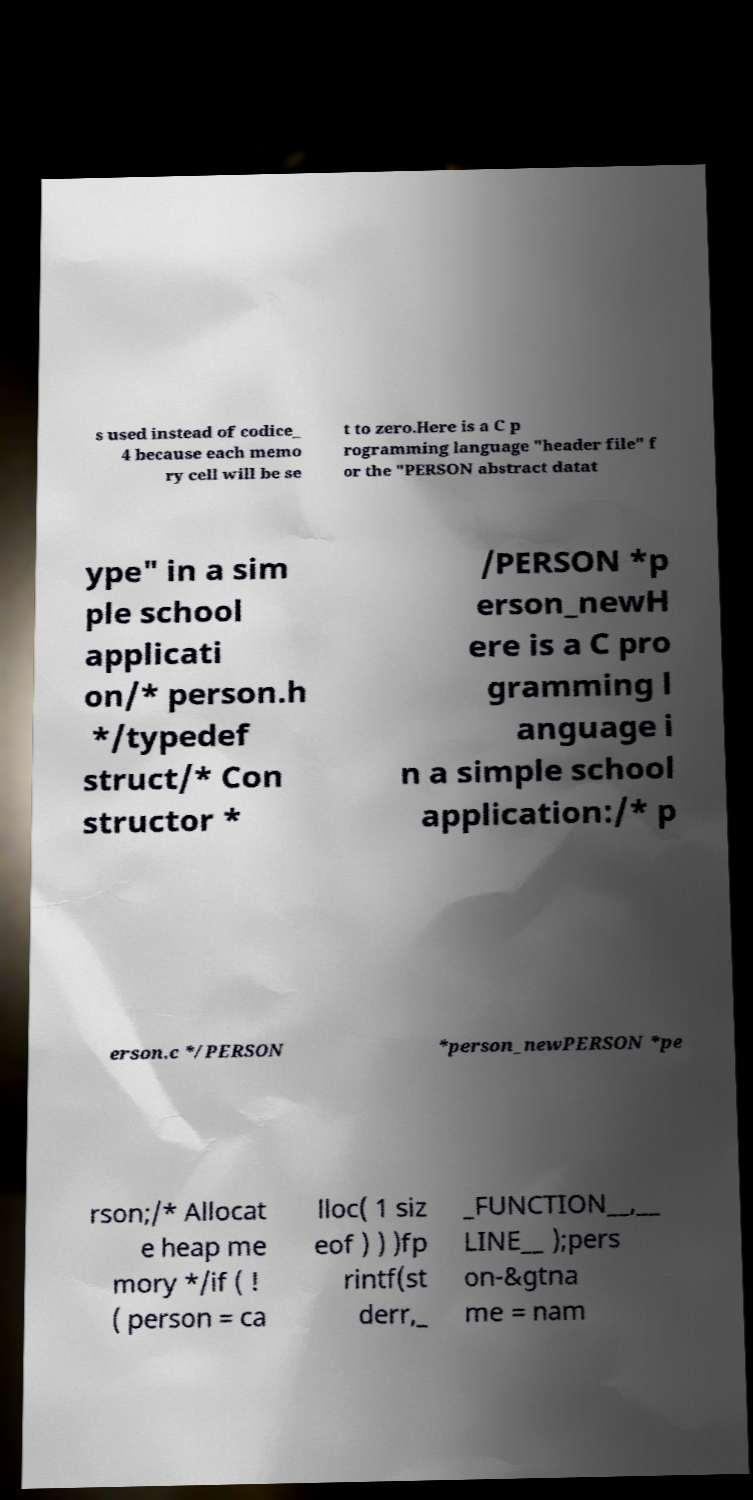Could you extract and type out the text from this image? s used instead of codice_ 4 because each memo ry cell will be se t to zero.Here is a C p rogramming language "header file" f or the "PERSON abstract datat ype" in a sim ple school applicati on/* person.h */typedef struct/* Con structor * /PERSON *p erson_newH ere is a C pro gramming l anguage i n a simple school application:/* p erson.c */PERSON *person_newPERSON *pe rson;/* Allocat e heap me mory */if ( ! ( person = ca lloc( 1 siz eof ) ) )fp rintf(st derr,_ _FUNCTION__,__ LINE__ );pers on-&gtna me = nam 